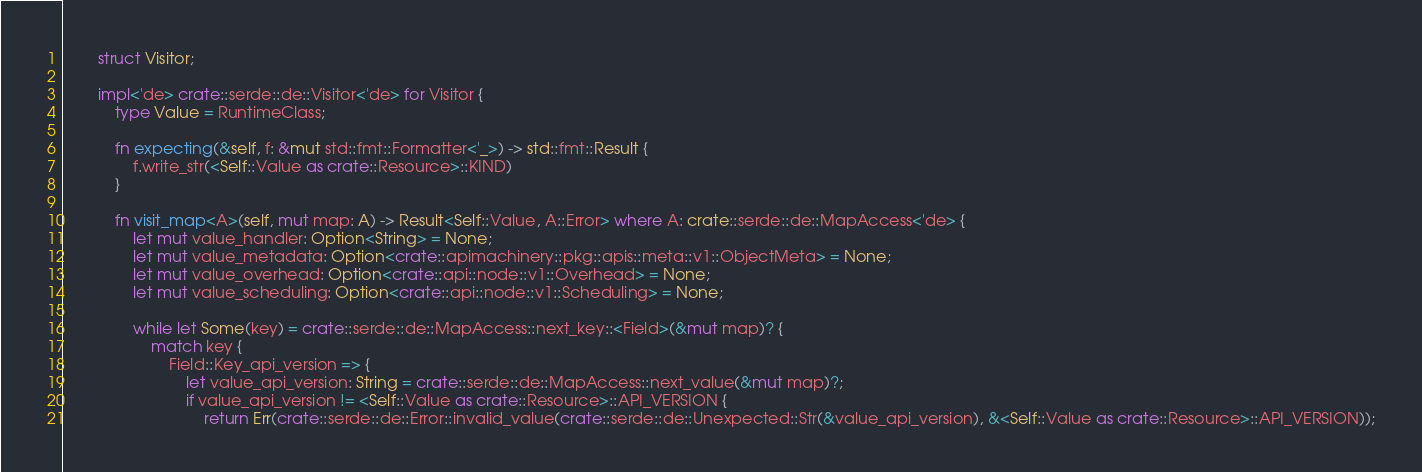Convert code to text. <code><loc_0><loc_0><loc_500><loc_500><_Rust_>
        struct Visitor;

        impl<'de> crate::serde::de::Visitor<'de> for Visitor {
            type Value = RuntimeClass;

            fn expecting(&self, f: &mut std::fmt::Formatter<'_>) -> std::fmt::Result {
                f.write_str(<Self::Value as crate::Resource>::KIND)
            }

            fn visit_map<A>(self, mut map: A) -> Result<Self::Value, A::Error> where A: crate::serde::de::MapAccess<'de> {
                let mut value_handler: Option<String> = None;
                let mut value_metadata: Option<crate::apimachinery::pkg::apis::meta::v1::ObjectMeta> = None;
                let mut value_overhead: Option<crate::api::node::v1::Overhead> = None;
                let mut value_scheduling: Option<crate::api::node::v1::Scheduling> = None;

                while let Some(key) = crate::serde::de::MapAccess::next_key::<Field>(&mut map)? {
                    match key {
                        Field::Key_api_version => {
                            let value_api_version: String = crate::serde::de::MapAccess::next_value(&mut map)?;
                            if value_api_version != <Self::Value as crate::Resource>::API_VERSION {
                                return Err(crate::serde::de::Error::invalid_value(crate::serde::de::Unexpected::Str(&value_api_version), &<Self::Value as crate::Resource>::API_VERSION));</code> 